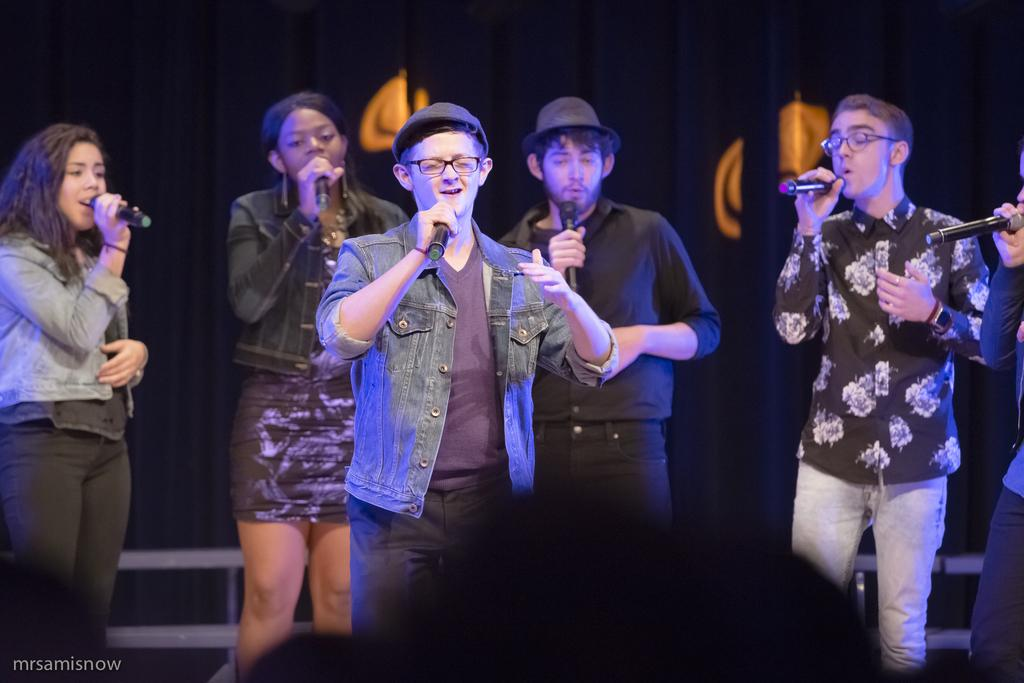What types of people are present in the image? There are men and women in the image. What are the men and women holding in the image? The men and women are holding microphones. How many porters are visible in the image? There are no porters present in the image. What type of insect can be seen flying around the microphones in the image? There are no insects or flies visible in the image. 